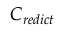Convert formula to latex. <formula><loc_0><loc_0><loc_500><loc_500>C _ { r e d i c t }</formula> 